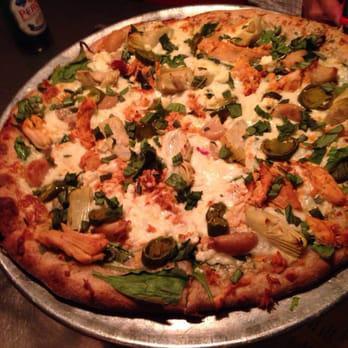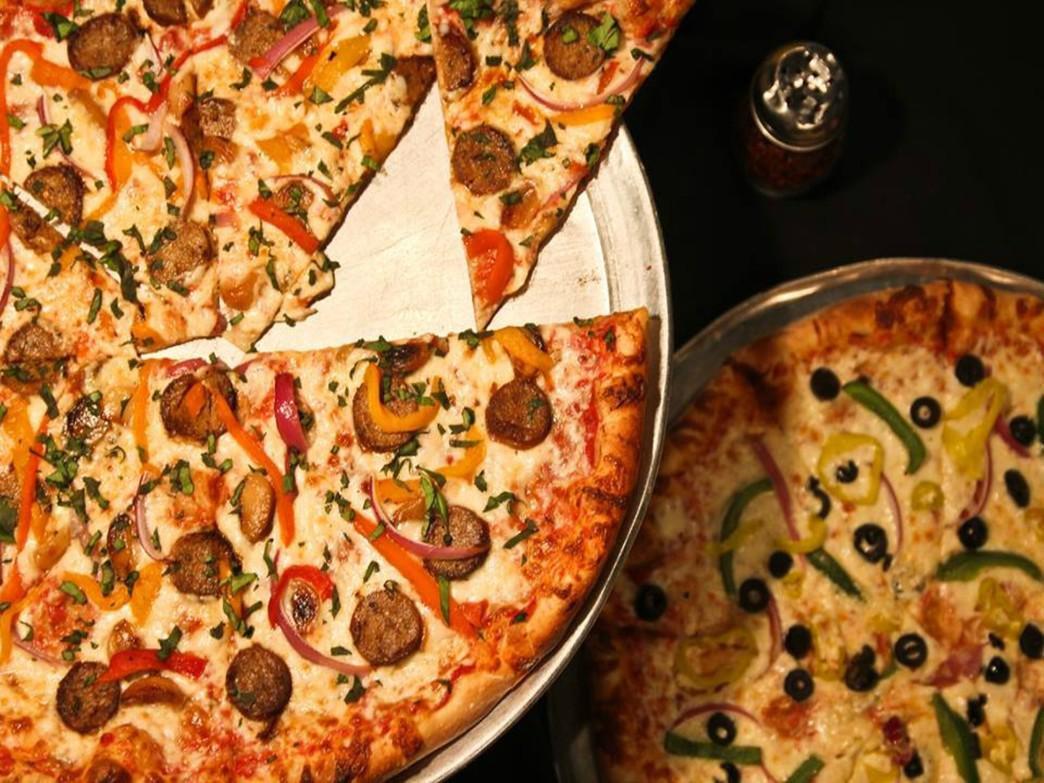The first image is the image on the left, the second image is the image on the right. Analyze the images presented: Is the assertion "Part of a round metal tray is visible between at least two slices of pizza in the right image." valid? Answer yes or no. Yes. The first image is the image on the left, the second image is the image on the right. Evaluate the accuracy of this statement regarding the images: "There are red peppers on exactly one pizza.". Is it true? Answer yes or no. Yes. 